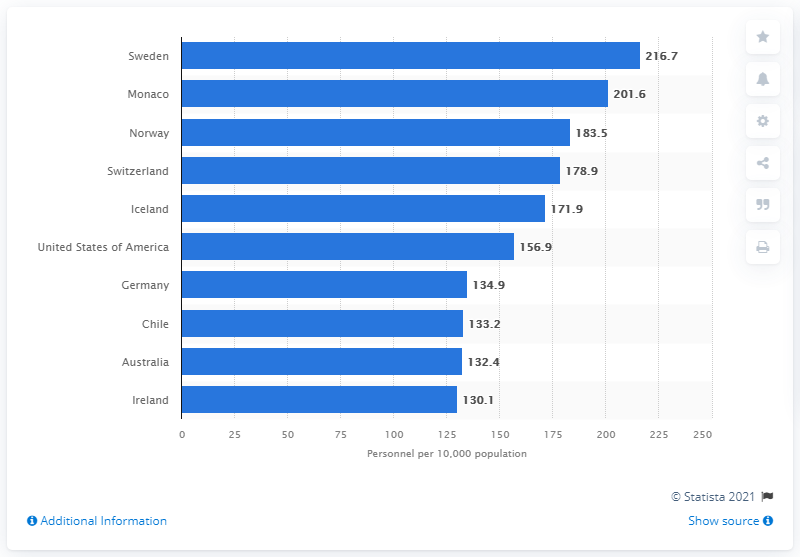Point out several critical features in this image. Sweden had the highest number of nursing and midwifery personnel per 10,000 inhabitants among all countries, according to the data. 